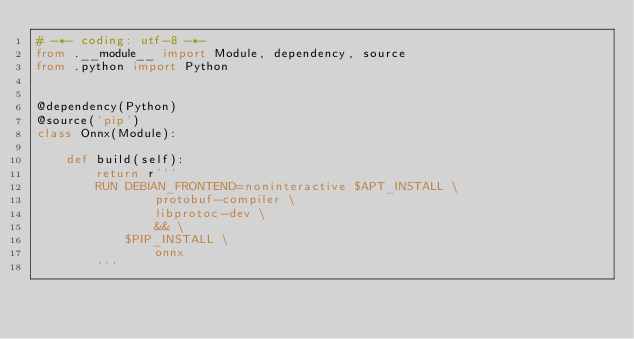<code> <loc_0><loc_0><loc_500><loc_500><_Python_># -*- coding: utf-8 -*-
from .__module__ import Module, dependency, source
from .python import Python


@dependency(Python)
@source('pip')
class Onnx(Module):

    def build(self):
        return r'''
        RUN DEBIAN_FRONTEND=noninteractive $APT_INSTALL \
                protobuf-compiler \
                libprotoc-dev \
                && \
            $PIP_INSTALL \
                onnx
        '''
</code> 